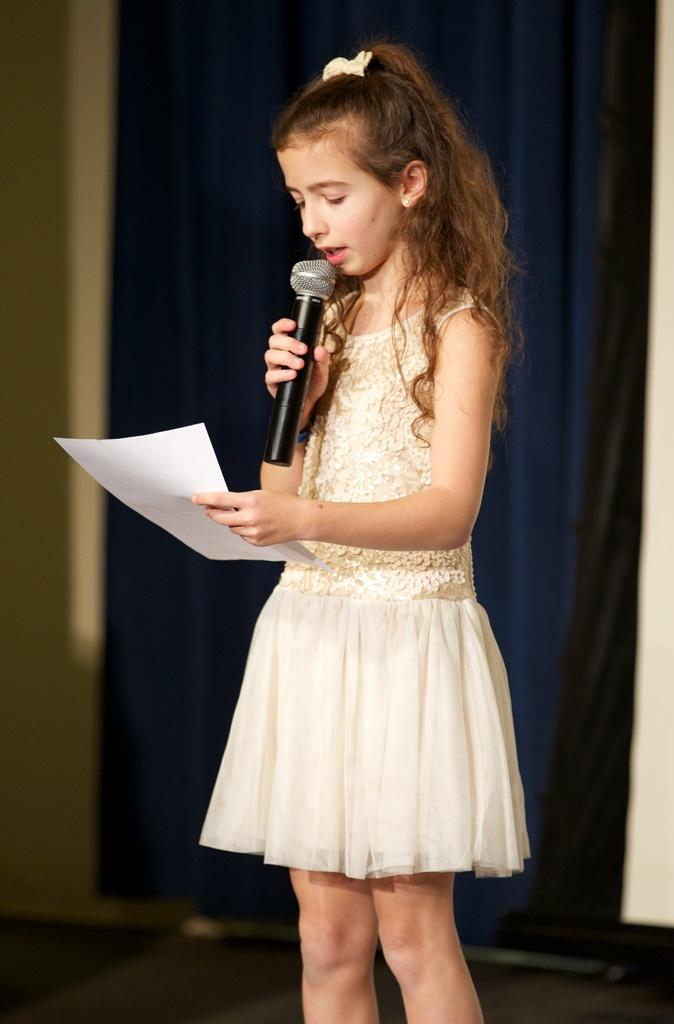Who is the main subject in the image? There is a girl in the image. What is the girl wearing? The girl is wearing a white dress. What is the girl holding in her right hand? The girl is holding a mic in her right hand. What is the girl holding in her left hand? The girl is holding a paper in her left hand. What can be seen in the background of the image? There are blue curtains in the background of the image. What type of square is visible in the image? There is no square present in the image. Is there a drum being played in the image? There is no drum or drumming activity depicted in the image. 